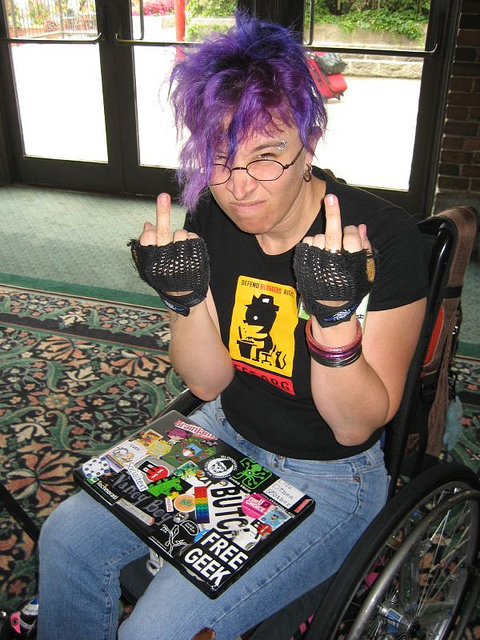Identify the text contained in this image. Vaney Boy FREE GEEK GEEK BUTCH 